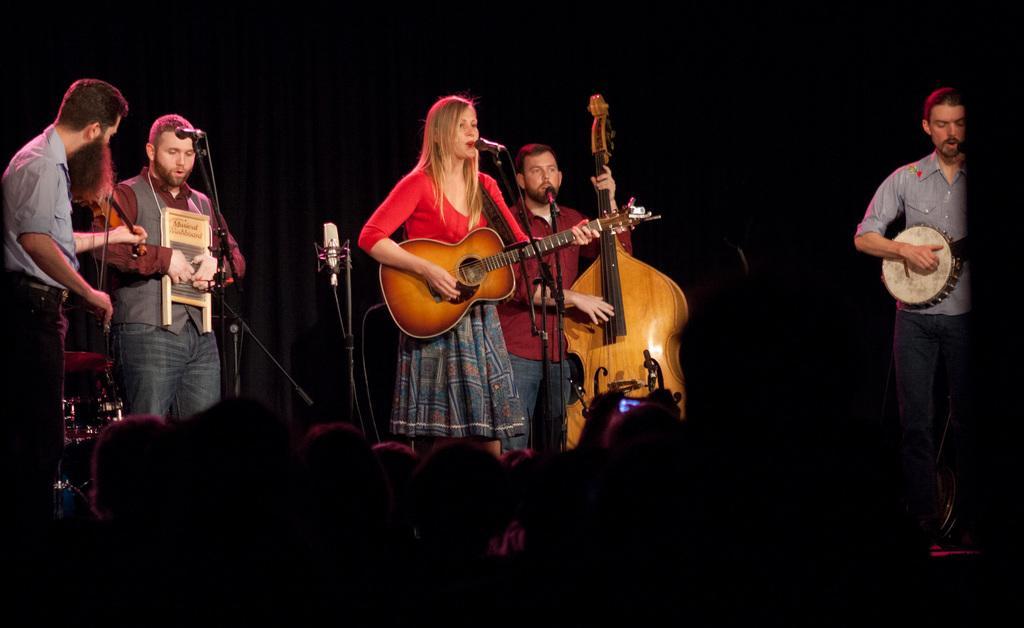Please provide a concise description of this image. In this picture we can see some group of persons playing instrument and in middle woman is singing on mic and playing guitar and beside to her man playing violin and on right side man is playing drum and on left side two man are singing and in front of them there is crowd of people. 